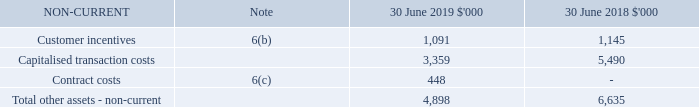6 Other assets (continued)
(a) Security deposits
Included in the security deposits was $8.8 million (2018: $4.2 million) relating to deposits held as security for bank guarantees.
(b) Customer incentives
Where customers are offered incentives in the form of free or discounted periods, the dollar value of the incentive is capitalised and amortised on a straight-line basis over the expected life of the contract.
(c) Contract Costs
From 1 July 2018, eligible costs that are expected to be recovered will be capitalised as a contract cost and amortised over the expected customer life.
How much was the security deposits in 2018? $4.2 million. What are the types of non-current assets? Contract costs, customer incentives, capitalised transaction costs. What was the total value of non-current assets in 2019?
Answer scale should be: thousand. 4,898. What was the percentage change in customer incentives between 2018 and 2019?
Answer scale should be: percent. (1,091 - 1,145) / 1,145 
Answer: -4.72. What was the percentage change in total other assets that are non-current between 2018 and 2019?
Answer scale should be: percent. (6,635 - 4,898) / 4,898 
Answer: 35.46. What was the sum of customer incentives and capitalised transaction costs in 2019?
Answer scale should be: thousand. 1,091 + 3,359 
Answer: 4450. 